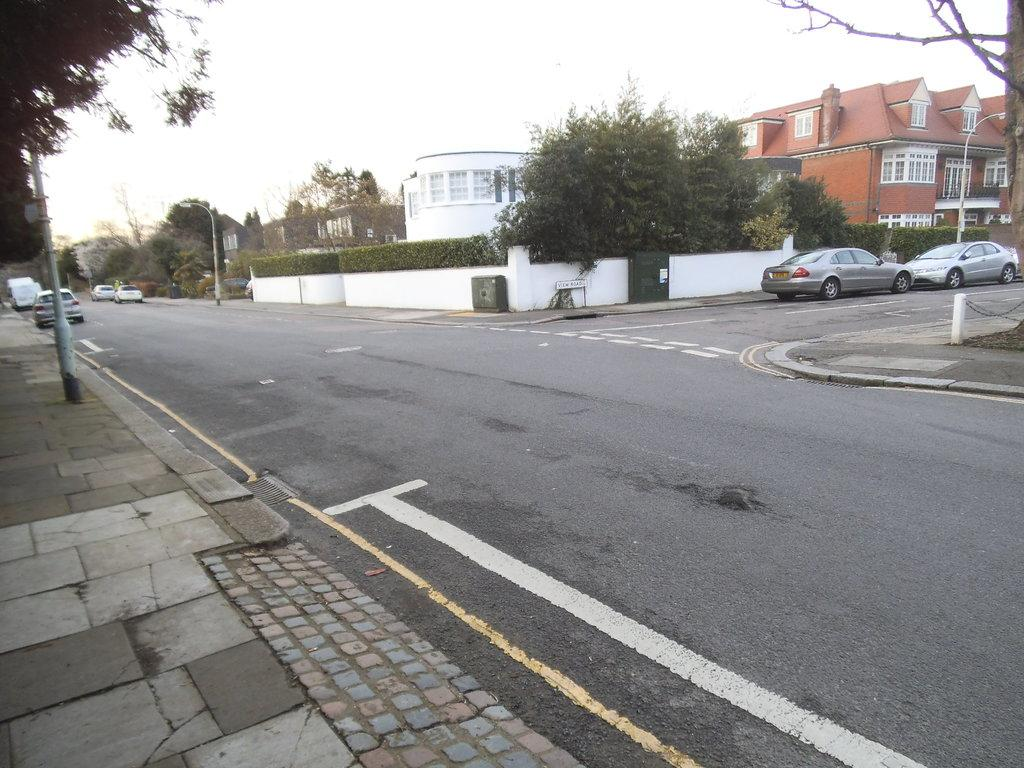What is the main feature of the image? There is a road in the image. What can be seen on the road? There are cars parked on the road. What is visible in the background of the image? There are buildings, plants, and trees in the background of the image. How is the sky depicted in the image? The sky is clear in the image. What language is being spoken by the trees in the image? Trees do not speak any language, so this cannot be determined from the image. 